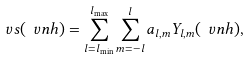<formula> <loc_0><loc_0><loc_500><loc_500>\ v s ( \ v n h ) = \sum _ { l = l _ { \min } } ^ { l _ { \max } } \sum _ { m = - l } ^ { l } a _ { l , m } Y _ { l , m } ( \ v n h ) ,</formula> 